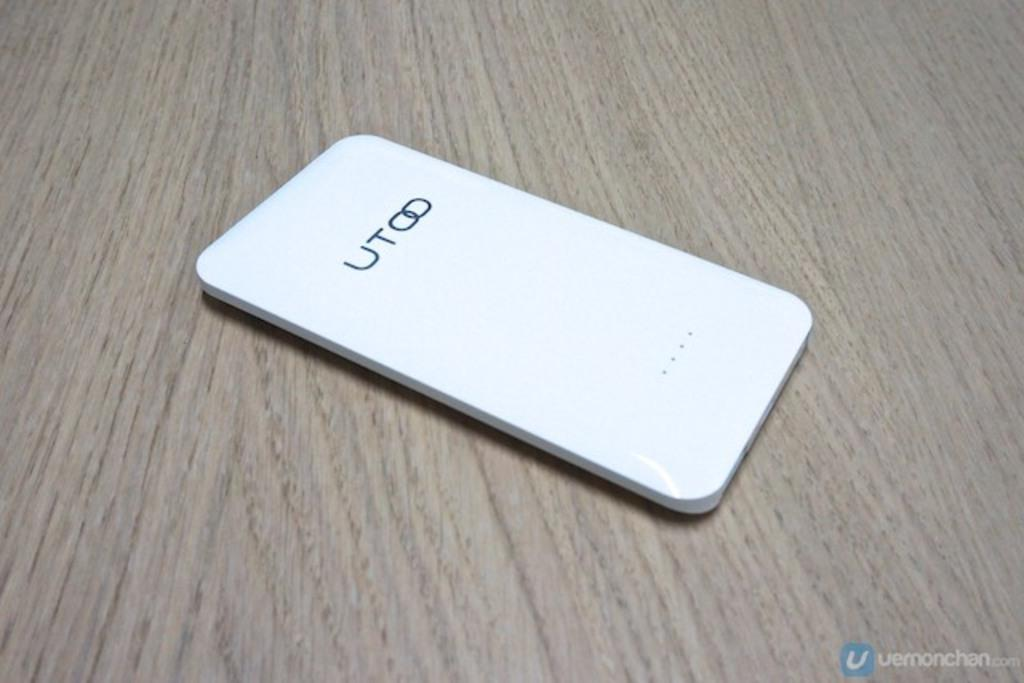<image>
Present a compact description of the photo's key features. a phone with the letters UT on the back 